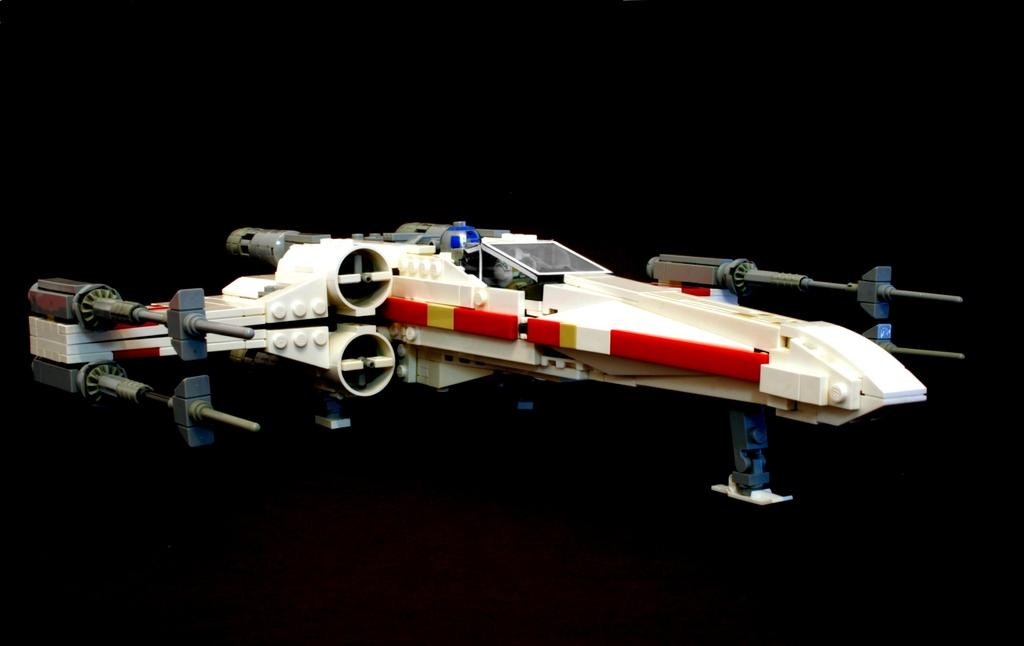What object can be seen in the image? There is a toy in the image. What type of hat is the toy wearing in the image? There is no hat present in the image, as the fact only mentions a toy. 